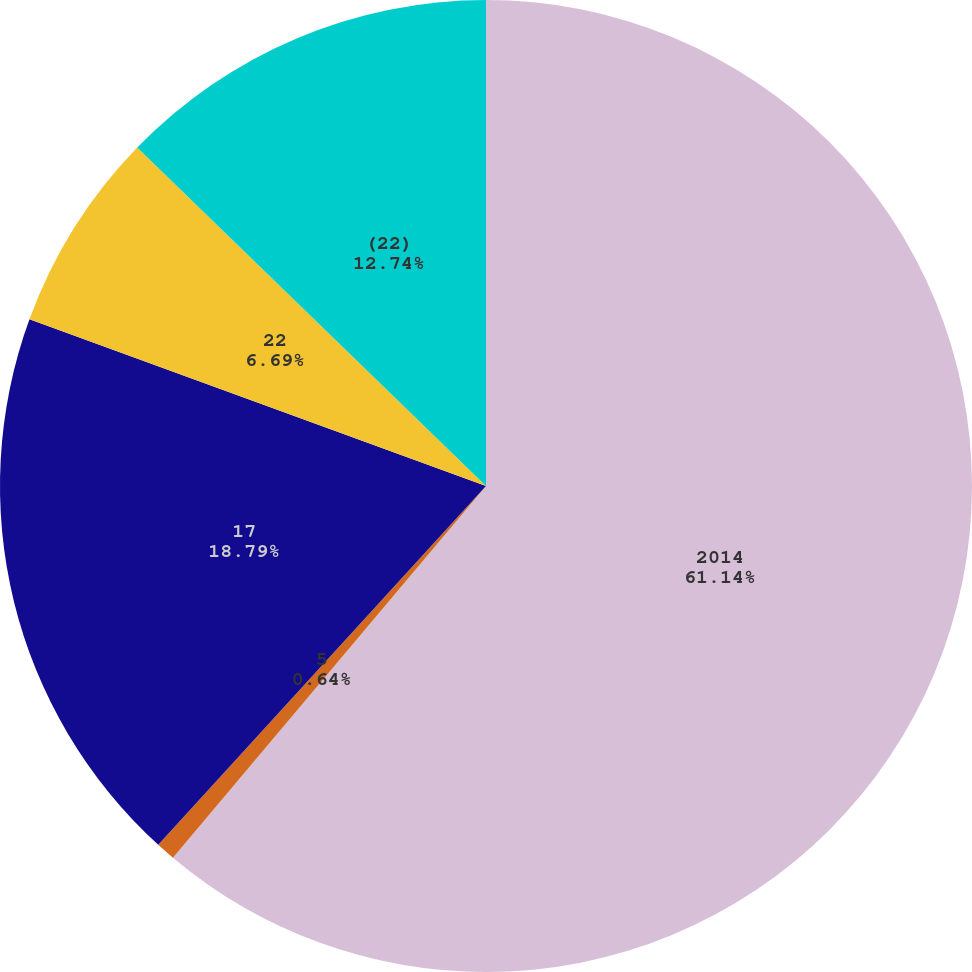Convert chart to OTSL. <chart><loc_0><loc_0><loc_500><loc_500><pie_chart><fcel>2014<fcel>5<fcel>17<fcel>22<fcel>(22)<nl><fcel>61.14%<fcel>0.64%<fcel>18.79%<fcel>6.69%<fcel>12.74%<nl></chart> 